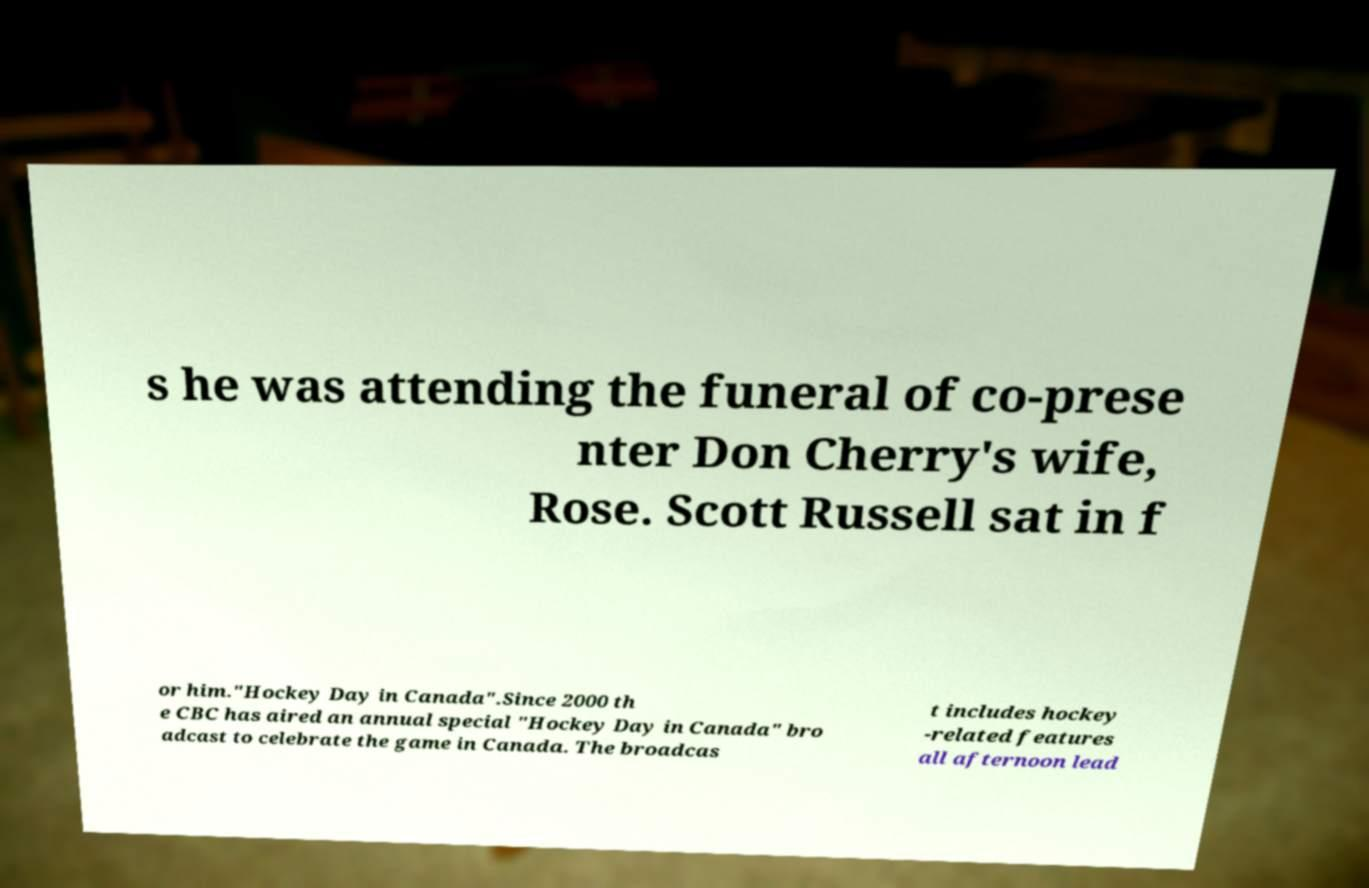There's text embedded in this image that I need extracted. Can you transcribe it verbatim? s he was attending the funeral of co-prese nter Don Cherry's wife, Rose. Scott Russell sat in f or him."Hockey Day in Canada".Since 2000 th e CBC has aired an annual special "Hockey Day in Canada" bro adcast to celebrate the game in Canada. The broadcas t includes hockey -related features all afternoon lead 